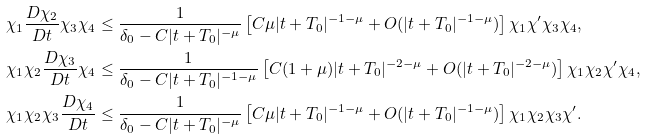<formula> <loc_0><loc_0><loc_500><loc_500>\chi _ { 1 } \frac { D \chi _ { 2 } } { D t } \chi _ { 3 } \chi _ { 4 } & \leq \frac { 1 } { \delta _ { 0 } - C | t + T _ { 0 } | ^ { - \mu } } \left [ C \mu | t + T _ { 0 } | ^ { - 1 - \mu } + O ( | t + T _ { 0 } | ^ { - 1 - \mu } ) \right ] \chi _ { 1 } \chi ^ { \prime } \chi _ { 3 } \chi _ { 4 } , \\ \chi _ { 1 } \chi _ { 2 } \frac { D \chi _ { 3 } } { D t } \chi _ { 4 } & \leq \frac { 1 } { \delta _ { 0 } - C | t + T _ { 0 } | ^ { - 1 - \mu } } \left [ C ( 1 + \mu ) | t + T _ { 0 } | ^ { - 2 - \mu } + O ( | t + T _ { 0 } | ^ { - 2 - \mu } ) \right ] \chi _ { 1 } \chi _ { 2 } \chi ^ { \prime } \chi _ { 4 } , \\ \chi _ { 1 } \chi _ { 2 } \chi _ { 3 } \frac { D \chi _ { 4 } } { D t } & \leq \frac { 1 } { \delta _ { 0 } - C | t + T _ { 0 } | ^ { - \mu } } \left [ C \mu | t + T _ { 0 } | ^ { - 1 - \mu } + O ( | t + T _ { 0 } | ^ { - 1 - \mu } ) \right ] \chi _ { 1 } \chi _ { 2 } \chi _ { 3 } \chi ^ { \prime } .</formula> 